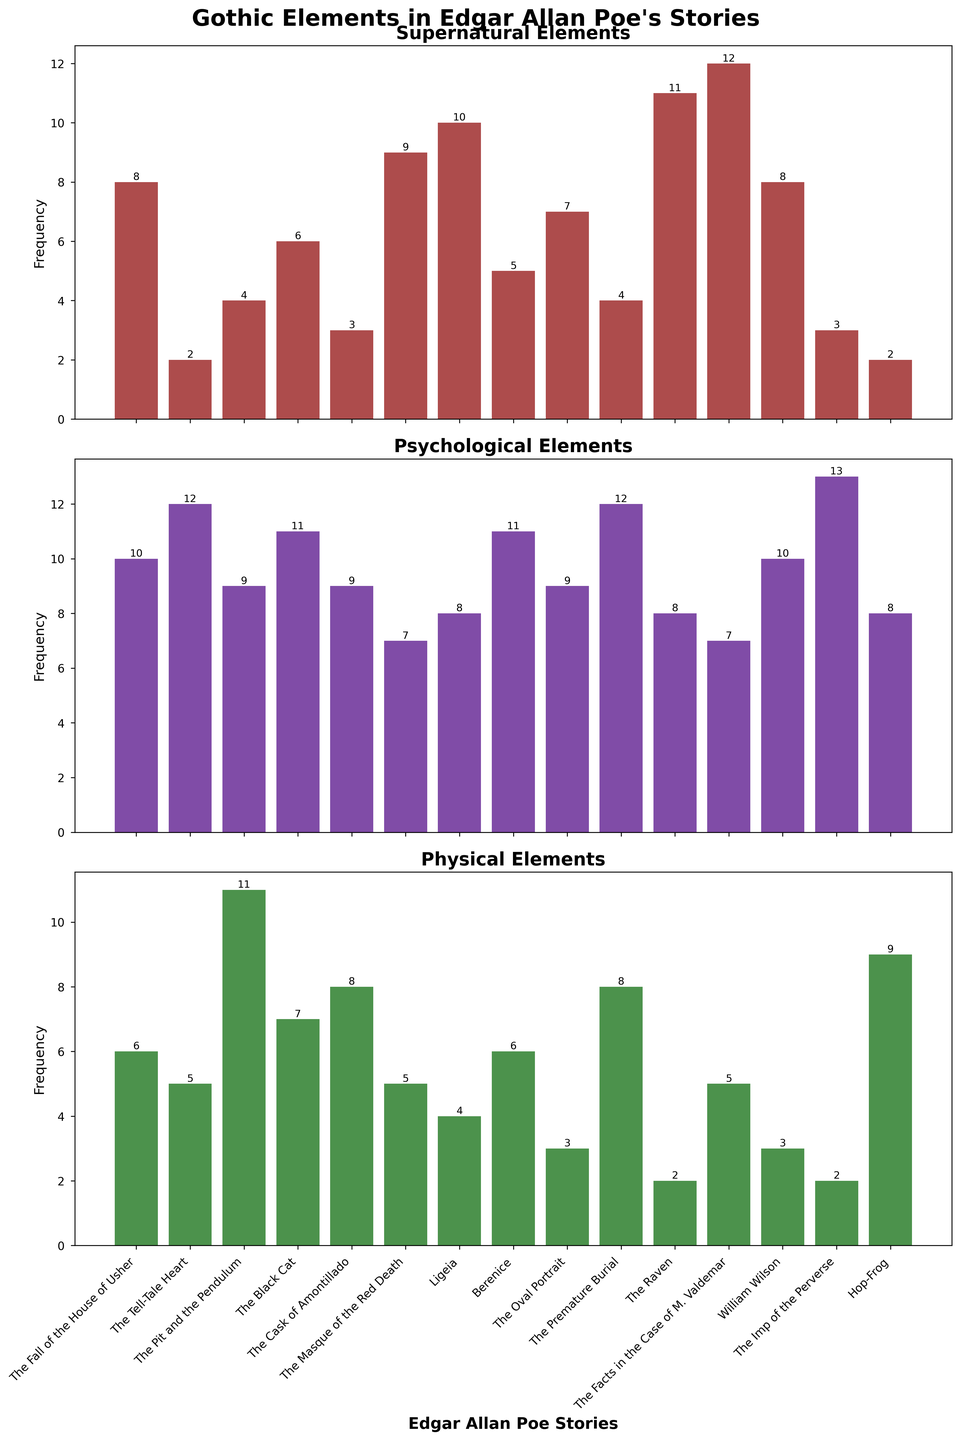What's the story with the highest frequency of supernatural elements? Look at the heights of the bars in the "Supernatural Elements" subplot and identify the tallest bar. The tallest bar corresponds to "The Facts in the Case of M. Valdemar" with a frequency of 12.
Answer: The Facts in the Case of M. Valdemar Which story has the lowest frequency of physical elements, and what is its value? Examine the heights of the bars in the "Physical Elements" subplot and find the shortest bar. The shortest bar corresponds to "The Raven" with a value of 2.
Answer: The Raven, 2 What is the combined frequency of psychological elements in "The Tell-Tale Heart" and "The Black Cat"? Identify the frequency of psychological elements for "The Tell-Tale Heart" (12) and "The Black Cat" (11). Sum these two values: 12 + 11 = 23.
Answer: 23 Between "Ligeia" and "The Oval Portrait", which story has a higher frequency of supernatural elements, and by how much? Compare the heights of the bars in the "Supernatural Elements" subplot for "Ligeia" (10) and "The Oval Portrait" (7). Calculate the difference: 10 - 7 = 3.
Answer: Ligeia, by 3 In which story do we see an equal frequency for supernatural and physical elements? Look for a story where the heights of the bars in the "Supernatural Elements" subplot match the heights of the bars in the "Physical Elements" subplot. "The Fall of the House of Usher" has equal frequencies (6).
Answer: The Fall of the House of Usher Which story has the highest frequency of psychological elements, and what is the value? Find the tallest bar in the "Psychological Elements" subplot. The tallest bar corresponds to "The Imp of the Perverse" with a frequency of 13.
Answer: The Imp of the Perverse, 13 What is the total frequency of physical elements combined across all stories? Sum the frequencies of physical elements from each story: 6 + 5 + 11 + 7 + 8 + 5 + 4 + 6 + 3 + 8 + 2 + 5 + 3 + 2 + 9 = 84.
Answer: 84 How much higher is the frequency of psychological elements in "The Tell-Tale Heart" compared to its supernatural elements? Identify the frequencies for psychological (12) and supernatural (2) elements in "The Tell-Tale Heart". Calculate the difference: 12 - 2 = 10.
Answer: 10 Is there any story where the frequency of physical elements is higher than both supernatural and psychological elements? Look for bars in the "Physical Elements" subplot that are taller than their counterparts in both other subplots. "The Pit and the Pendulum" is the story where this occurs (11 physical, 4 supernatural, 9 psychological).
Answer: The Pit and the Pendulum 